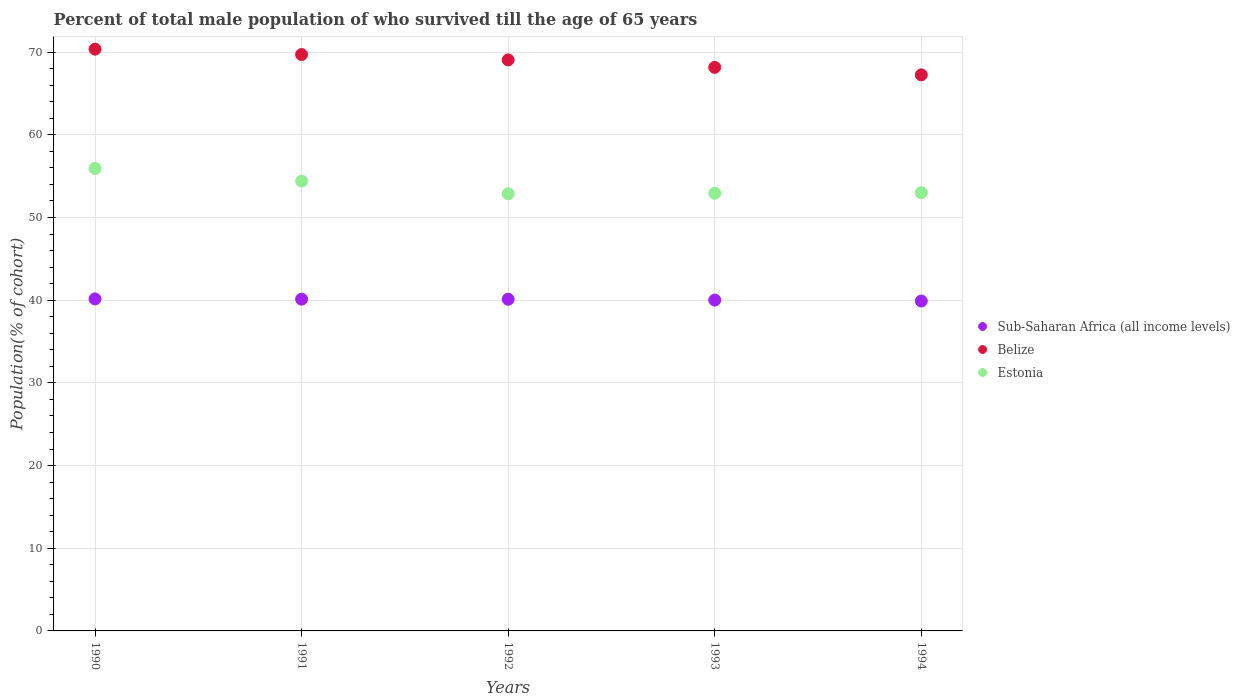Is the number of dotlines equal to the number of legend labels?
Ensure brevity in your answer.  Yes. What is the percentage of total male population who survived till the age of 65 years in Belize in 1994?
Offer a very short reply. 67.26. Across all years, what is the maximum percentage of total male population who survived till the age of 65 years in Belize?
Offer a very short reply. 70.36. Across all years, what is the minimum percentage of total male population who survived till the age of 65 years in Estonia?
Offer a terse response. 52.88. What is the total percentage of total male population who survived till the age of 65 years in Estonia in the graph?
Offer a very short reply. 269.15. What is the difference between the percentage of total male population who survived till the age of 65 years in Estonia in 1990 and that in 1994?
Your answer should be very brief. 2.94. What is the difference between the percentage of total male population who survived till the age of 65 years in Belize in 1992 and the percentage of total male population who survived till the age of 65 years in Sub-Saharan Africa (all income levels) in 1990?
Make the answer very short. 28.91. What is the average percentage of total male population who survived till the age of 65 years in Belize per year?
Give a very brief answer. 68.91. In the year 1990, what is the difference between the percentage of total male population who survived till the age of 65 years in Belize and percentage of total male population who survived till the age of 65 years in Sub-Saharan Africa (all income levels)?
Make the answer very short. 30.21. In how many years, is the percentage of total male population who survived till the age of 65 years in Estonia greater than 18 %?
Give a very brief answer. 5. What is the ratio of the percentage of total male population who survived till the age of 65 years in Sub-Saharan Africa (all income levels) in 1993 to that in 1994?
Your response must be concise. 1. What is the difference between the highest and the second highest percentage of total male population who survived till the age of 65 years in Belize?
Your answer should be very brief. 0.65. What is the difference between the highest and the lowest percentage of total male population who survived till the age of 65 years in Belize?
Your response must be concise. 3.1. In how many years, is the percentage of total male population who survived till the age of 65 years in Belize greater than the average percentage of total male population who survived till the age of 65 years in Belize taken over all years?
Make the answer very short. 3. Is the sum of the percentage of total male population who survived till the age of 65 years in Belize in 1990 and 1993 greater than the maximum percentage of total male population who survived till the age of 65 years in Estonia across all years?
Your answer should be compact. Yes. Is it the case that in every year, the sum of the percentage of total male population who survived till the age of 65 years in Estonia and percentage of total male population who survived till the age of 65 years in Sub-Saharan Africa (all income levels)  is greater than the percentage of total male population who survived till the age of 65 years in Belize?
Your answer should be compact. Yes. Does the percentage of total male population who survived till the age of 65 years in Sub-Saharan Africa (all income levels) monotonically increase over the years?
Ensure brevity in your answer.  No. Is the percentage of total male population who survived till the age of 65 years in Sub-Saharan Africa (all income levels) strictly less than the percentage of total male population who survived till the age of 65 years in Belize over the years?
Make the answer very short. Yes. How many dotlines are there?
Offer a very short reply. 3. How many years are there in the graph?
Provide a succinct answer. 5. Are the values on the major ticks of Y-axis written in scientific E-notation?
Ensure brevity in your answer.  No. How are the legend labels stacked?
Ensure brevity in your answer.  Vertical. What is the title of the graph?
Keep it short and to the point. Percent of total male population of who survived till the age of 65 years. Does "Cyprus" appear as one of the legend labels in the graph?
Give a very brief answer. No. What is the label or title of the X-axis?
Offer a terse response. Years. What is the label or title of the Y-axis?
Ensure brevity in your answer.  Population(% of cohort). What is the Population(% of cohort) in Sub-Saharan Africa (all income levels) in 1990?
Offer a very short reply. 40.15. What is the Population(% of cohort) of Belize in 1990?
Give a very brief answer. 70.36. What is the Population(% of cohort) of Estonia in 1990?
Provide a short and direct response. 55.94. What is the Population(% of cohort) of Sub-Saharan Africa (all income levels) in 1991?
Keep it short and to the point. 40.13. What is the Population(% of cohort) of Belize in 1991?
Provide a short and direct response. 69.72. What is the Population(% of cohort) in Estonia in 1991?
Make the answer very short. 54.41. What is the Population(% of cohort) in Sub-Saharan Africa (all income levels) in 1992?
Your answer should be compact. 40.12. What is the Population(% of cohort) of Belize in 1992?
Make the answer very short. 69.07. What is the Population(% of cohort) in Estonia in 1992?
Your answer should be compact. 52.88. What is the Population(% of cohort) of Sub-Saharan Africa (all income levels) in 1993?
Your answer should be very brief. 40.02. What is the Population(% of cohort) in Belize in 1993?
Ensure brevity in your answer.  68.16. What is the Population(% of cohort) of Estonia in 1993?
Ensure brevity in your answer.  52.94. What is the Population(% of cohort) of Sub-Saharan Africa (all income levels) in 1994?
Provide a short and direct response. 39.9. What is the Population(% of cohort) in Belize in 1994?
Provide a succinct answer. 67.26. What is the Population(% of cohort) of Estonia in 1994?
Your answer should be very brief. 52.99. Across all years, what is the maximum Population(% of cohort) of Sub-Saharan Africa (all income levels)?
Give a very brief answer. 40.15. Across all years, what is the maximum Population(% of cohort) of Belize?
Your response must be concise. 70.36. Across all years, what is the maximum Population(% of cohort) of Estonia?
Your answer should be compact. 55.94. Across all years, what is the minimum Population(% of cohort) of Sub-Saharan Africa (all income levels)?
Offer a terse response. 39.9. Across all years, what is the minimum Population(% of cohort) in Belize?
Provide a short and direct response. 67.26. Across all years, what is the minimum Population(% of cohort) of Estonia?
Provide a succinct answer. 52.88. What is the total Population(% of cohort) of Sub-Saharan Africa (all income levels) in the graph?
Make the answer very short. 200.31. What is the total Population(% of cohort) in Belize in the graph?
Your answer should be compact. 344.57. What is the total Population(% of cohort) of Estonia in the graph?
Give a very brief answer. 269.15. What is the difference between the Population(% of cohort) of Sub-Saharan Africa (all income levels) in 1990 and that in 1991?
Your response must be concise. 0.03. What is the difference between the Population(% of cohort) in Belize in 1990 and that in 1991?
Offer a terse response. 0.65. What is the difference between the Population(% of cohort) of Estonia in 1990 and that in 1991?
Your answer should be compact. 1.53. What is the difference between the Population(% of cohort) of Sub-Saharan Africa (all income levels) in 1990 and that in 1992?
Keep it short and to the point. 0.04. What is the difference between the Population(% of cohort) of Belize in 1990 and that in 1992?
Give a very brief answer. 1.3. What is the difference between the Population(% of cohort) in Estonia in 1990 and that in 1992?
Keep it short and to the point. 3.06. What is the difference between the Population(% of cohort) in Sub-Saharan Africa (all income levels) in 1990 and that in 1993?
Your answer should be very brief. 0.14. What is the difference between the Population(% of cohort) of Belize in 1990 and that in 1993?
Provide a short and direct response. 2.2. What is the difference between the Population(% of cohort) of Estonia in 1990 and that in 1993?
Give a very brief answer. 3. What is the difference between the Population(% of cohort) of Sub-Saharan Africa (all income levels) in 1990 and that in 1994?
Offer a terse response. 0.26. What is the difference between the Population(% of cohort) in Belize in 1990 and that in 1994?
Provide a short and direct response. 3.1. What is the difference between the Population(% of cohort) of Estonia in 1990 and that in 1994?
Your response must be concise. 2.94. What is the difference between the Population(% of cohort) of Sub-Saharan Africa (all income levels) in 1991 and that in 1992?
Ensure brevity in your answer.  0.01. What is the difference between the Population(% of cohort) of Belize in 1991 and that in 1992?
Your response must be concise. 0.65. What is the difference between the Population(% of cohort) of Estonia in 1991 and that in 1992?
Ensure brevity in your answer.  1.53. What is the difference between the Population(% of cohort) of Sub-Saharan Africa (all income levels) in 1991 and that in 1993?
Your answer should be very brief. 0.11. What is the difference between the Population(% of cohort) of Belize in 1991 and that in 1993?
Offer a terse response. 1.55. What is the difference between the Population(% of cohort) of Estonia in 1991 and that in 1993?
Your answer should be very brief. 1.47. What is the difference between the Population(% of cohort) in Sub-Saharan Africa (all income levels) in 1991 and that in 1994?
Give a very brief answer. 0.23. What is the difference between the Population(% of cohort) of Belize in 1991 and that in 1994?
Provide a succinct answer. 2.45. What is the difference between the Population(% of cohort) of Estonia in 1991 and that in 1994?
Your answer should be compact. 1.41. What is the difference between the Population(% of cohort) of Sub-Saharan Africa (all income levels) in 1992 and that in 1993?
Your answer should be very brief. 0.1. What is the difference between the Population(% of cohort) of Belize in 1992 and that in 1993?
Provide a short and direct response. 0.9. What is the difference between the Population(% of cohort) in Estonia in 1992 and that in 1993?
Your answer should be very brief. -0.06. What is the difference between the Population(% of cohort) of Sub-Saharan Africa (all income levels) in 1992 and that in 1994?
Make the answer very short. 0.22. What is the difference between the Population(% of cohort) in Belize in 1992 and that in 1994?
Your answer should be very brief. 1.81. What is the difference between the Population(% of cohort) in Estonia in 1992 and that in 1994?
Provide a succinct answer. -0.12. What is the difference between the Population(% of cohort) in Sub-Saharan Africa (all income levels) in 1993 and that in 1994?
Make the answer very short. 0.12. What is the difference between the Population(% of cohort) in Belize in 1993 and that in 1994?
Provide a short and direct response. 0.9. What is the difference between the Population(% of cohort) in Estonia in 1993 and that in 1994?
Your answer should be very brief. -0.06. What is the difference between the Population(% of cohort) of Sub-Saharan Africa (all income levels) in 1990 and the Population(% of cohort) of Belize in 1991?
Give a very brief answer. -29.56. What is the difference between the Population(% of cohort) in Sub-Saharan Africa (all income levels) in 1990 and the Population(% of cohort) in Estonia in 1991?
Your response must be concise. -14.25. What is the difference between the Population(% of cohort) in Belize in 1990 and the Population(% of cohort) in Estonia in 1991?
Make the answer very short. 15.96. What is the difference between the Population(% of cohort) in Sub-Saharan Africa (all income levels) in 1990 and the Population(% of cohort) in Belize in 1992?
Make the answer very short. -28.91. What is the difference between the Population(% of cohort) of Sub-Saharan Africa (all income levels) in 1990 and the Population(% of cohort) of Estonia in 1992?
Ensure brevity in your answer.  -12.72. What is the difference between the Population(% of cohort) in Belize in 1990 and the Population(% of cohort) in Estonia in 1992?
Offer a terse response. 17.49. What is the difference between the Population(% of cohort) of Sub-Saharan Africa (all income levels) in 1990 and the Population(% of cohort) of Belize in 1993?
Keep it short and to the point. -28.01. What is the difference between the Population(% of cohort) in Sub-Saharan Africa (all income levels) in 1990 and the Population(% of cohort) in Estonia in 1993?
Keep it short and to the point. -12.78. What is the difference between the Population(% of cohort) in Belize in 1990 and the Population(% of cohort) in Estonia in 1993?
Provide a succinct answer. 17.43. What is the difference between the Population(% of cohort) in Sub-Saharan Africa (all income levels) in 1990 and the Population(% of cohort) in Belize in 1994?
Offer a terse response. -27.11. What is the difference between the Population(% of cohort) in Sub-Saharan Africa (all income levels) in 1990 and the Population(% of cohort) in Estonia in 1994?
Keep it short and to the point. -12.84. What is the difference between the Population(% of cohort) in Belize in 1990 and the Population(% of cohort) in Estonia in 1994?
Provide a short and direct response. 17.37. What is the difference between the Population(% of cohort) in Sub-Saharan Africa (all income levels) in 1991 and the Population(% of cohort) in Belize in 1992?
Give a very brief answer. -28.94. What is the difference between the Population(% of cohort) in Sub-Saharan Africa (all income levels) in 1991 and the Population(% of cohort) in Estonia in 1992?
Keep it short and to the point. -12.75. What is the difference between the Population(% of cohort) of Belize in 1991 and the Population(% of cohort) of Estonia in 1992?
Your answer should be compact. 16.84. What is the difference between the Population(% of cohort) of Sub-Saharan Africa (all income levels) in 1991 and the Population(% of cohort) of Belize in 1993?
Offer a very short reply. -28.04. What is the difference between the Population(% of cohort) of Sub-Saharan Africa (all income levels) in 1991 and the Population(% of cohort) of Estonia in 1993?
Your answer should be very brief. -12.81. What is the difference between the Population(% of cohort) of Belize in 1991 and the Population(% of cohort) of Estonia in 1993?
Give a very brief answer. 16.78. What is the difference between the Population(% of cohort) of Sub-Saharan Africa (all income levels) in 1991 and the Population(% of cohort) of Belize in 1994?
Your answer should be very brief. -27.13. What is the difference between the Population(% of cohort) of Sub-Saharan Africa (all income levels) in 1991 and the Population(% of cohort) of Estonia in 1994?
Provide a short and direct response. -12.87. What is the difference between the Population(% of cohort) of Belize in 1991 and the Population(% of cohort) of Estonia in 1994?
Offer a very short reply. 16.72. What is the difference between the Population(% of cohort) of Sub-Saharan Africa (all income levels) in 1992 and the Population(% of cohort) of Belize in 1993?
Offer a very short reply. -28.05. What is the difference between the Population(% of cohort) in Sub-Saharan Africa (all income levels) in 1992 and the Population(% of cohort) in Estonia in 1993?
Provide a succinct answer. -12.82. What is the difference between the Population(% of cohort) of Belize in 1992 and the Population(% of cohort) of Estonia in 1993?
Offer a terse response. 16.13. What is the difference between the Population(% of cohort) of Sub-Saharan Africa (all income levels) in 1992 and the Population(% of cohort) of Belize in 1994?
Provide a succinct answer. -27.15. What is the difference between the Population(% of cohort) in Sub-Saharan Africa (all income levels) in 1992 and the Population(% of cohort) in Estonia in 1994?
Give a very brief answer. -12.88. What is the difference between the Population(% of cohort) of Belize in 1992 and the Population(% of cohort) of Estonia in 1994?
Provide a succinct answer. 16.07. What is the difference between the Population(% of cohort) of Sub-Saharan Africa (all income levels) in 1993 and the Population(% of cohort) of Belize in 1994?
Your response must be concise. -27.24. What is the difference between the Population(% of cohort) of Sub-Saharan Africa (all income levels) in 1993 and the Population(% of cohort) of Estonia in 1994?
Make the answer very short. -12.98. What is the difference between the Population(% of cohort) in Belize in 1993 and the Population(% of cohort) in Estonia in 1994?
Give a very brief answer. 15.17. What is the average Population(% of cohort) in Sub-Saharan Africa (all income levels) per year?
Offer a terse response. 40.06. What is the average Population(% of cohort) of Belize per year?
Make the answer very short. 68.91. What is the average Population(% of cohort) in Estonia per year?
Ensure brevity in your answer.  53.83. In the year 1990, what is the difference between the Population(% of cohort) of Sub-Saharan Africa (all income levels) and Population(% of cohort) of Belize?
Offer a very short reply. -30.21. In the year 1990, what is the difference between the Population(% of cohort) of Sub-Saharan Africa (all income levels) and Population(% of cohort) of Estonia?
Ensure brevity in your answer.  -15.78. In the year 1990, what is the difference between the Population(% of cohort) of Belize and Population(% of cohort) of Estonia?
Provide a short and direct response. 14.43. In the year 1991, what is the difference between the Population(% of cohort) in Sub-Saharan Africa (all income levels) and Population(% of cohort) in Belize?
Your answer should be compact. -29.59. In the year 1991, what is the difference between the Population(% of cohort) in Sub-Saharan Africa (all income levels) and Population(% of cohort) in Estonia?
Provide a short and direct response. -14.28. In the year 1991, what is the difference between the Population(% of cohort) of Belize and Population(% of cohort) of Estonia?
Your response must be concise. 15.31. In the year 1992, what is the difference between the Population(% of cohort) of Sub-Saharan Africa (all income levels) and Population(% of cohort) of Belize?
Your answer should be compact. -28.95. In the year 1992, what is the difference between the Population(% of cohort) of Sub-Saharan Africa (all income levels) and Population(% of cohort) of Estonia?
Your response must be concise. -12.76. In the year 1992, what is the difference between the Population(% of cohort) in Belize and Population(% of cohort) in Estonia?
Ensure brevity in your answer.  16.19. In the year 1993, what is the difference between the Population(% of cohort) in Sub-Saharan Africa (all income levels) and Population(% of cohort) in Belize?
Your answer should be compact. -28.15. In the year 1993, what is the difference between the Population(% of cohort) in Sub-Saharan Africa (all income levels) and Population(% of cohort) in Estonia?
Provide a succinct answer. -12.92. In the year 1993, what is the difference between the Population(% of cohort) of Belize and Population(% of cohort) of Estonia?
Your response must be concise. 15.23. In the year 1994, what is the difference between the Population(% of cohort) of Sub-Saharan Africa (all income levels) and Population(% of cohort) of Belize?
Offer a terse response. -27.36. In the year 1994, what is the difference between the Population(% of cohort) in Sub-Saharan Africa (all income levels) and Population(% of cohort) in Estonia?
Ensure brevity in your answer.  -13.1. In the year 1994, what is the difference between the Population(% of cohort) of Belize and Population(% of cohort) of Estonia?
Keep it short and to the point. 14.27. What is the ratio of the Population(% of cohort) in Sub-Saharan Africa (all income levels) in 1990 to that in 1991?
Your response must be concise. 1. What is the ratio of the Population(% of cohort) in Belize in 1990 to that in 1991?
Make the answer very short. 1.01. What is the ratio of the Population(% of cohort) of Estonia in 1990 to that in 1991?
Ensure brevity in your answer.  1.03. What is the ratio of the Population(% of cohort) of Belize in 1990 to that in 1992?
Give a very brief answer. 1.02. What is the ratio of the Population(% of cohort) in Estonia in 1990 to that in 1992?
Your answer should be very brief. 1.06. What is the ratio of the Population(% of cohort) of Belize in 1990 to that in 1993?
Offer a very short reply. 1.03. What is the ratio of the Population(% of cohort) in Estonia in 1990 to that in 1993?
Your response must be concise. 1.06. What is the ratio of the Population(% of cohort) in Sub-Saharan Africa (all income levels) in 1990 to that in 1994?
Give a very brief answer. 1.01. What is the ratio of the Population(% of cohort) in Belize in 1990 to that in 1994?
Your answer should be compact. 1.05. What is the ratio of the Population(% of cohort) in Estonia in 1990 to that in 1994?
Give a very brief answer. 1.06. What is the ratio of the Population(% of cohort) in Sub-Saharan Africa (all income levels) in 1991 to that in 1992?
Provide a succinct answer. 1. What is the ratio of the Population(% of cohort) in Belize in 1991 to that in 1992?
Keep it short and to the point. 1.01. What is the ratio of the Population(% of cohort) of Estonia in 1991 to that in 1992?
Your answer should be compact. 1.03. What is the ratio of the Population(% of cohort) in Sub-Saharan Africa (all income levels) in 1991 to that in 1993?
Give a very brief answer. 1. What is the ratio of the Population(% of cohort) in Belize in 1991 to that in 1993?
Give a very brief answer. 1.02. What is the ratio of the Population(% of cohort) in Estonia in 1991 to that in 1993?
Ensure brevity in your answer.  1.03. What is the ratio of the Population(% of cohort) of Belize in 1991 to that in 1994?
Keep it short and to the point. 1.04. What is the ratio of the Population(% of cohort) of Estonia in 1991 to that in 1994?
Provide a short and direct response. 1.03. What is the ratio of the Population(% of cohort) in Belize in 1992 to that in 1993?
Provide a succinct answer. 1.01. What is the ratio of the Population(% of cohort) of Sub-Saharan Africa (all income levels) in 1992 to that in 1994?
Make the answer very short. 1.01. What is the ratio of the Population(% of cohort) in Belize in 1992 to that in 1994?
Provide a succinct answer. 1.03. What is the ratio of the Population(% of cohort) in Estonia in 1992 to that in 1994?
Your response must be concise. 1. What is the ratio of the Population(% of cohort) in Belize in 1993 to that in 1994?
Your answer should be very brief. 1.01. What is the ratio of the Population(% of cohort) in Estonia in 1993 to that in 1994?
Your answer should be compact. 1. What is the difference between the highest and the second highest Population(% of cohort) of Sub-Saharan Africa (all income levels)?
Your answer should be compact. 0.03. What is the difference between the highest and the second highest Population(% of cohort) of Belize?
Make the answer very short. 0.65. What is the difference between the highest and the second highest Population(% of cohort) of Estonia?
Your answer should be compact. 1.53. What is the difference between the highest and the lowest Population(% of cohort) in Sub-Saharan Africa (all income levels)?
Provide a short and direct response. 0.26. What is the difference between the highest and the lowest Population(% of cohort) in Belize?
Provide a short and direct response. 3.1. What is the difference between the highest and the lowest Population(% of cohort) of Estonia?
Offer a terse response. 3.06. 